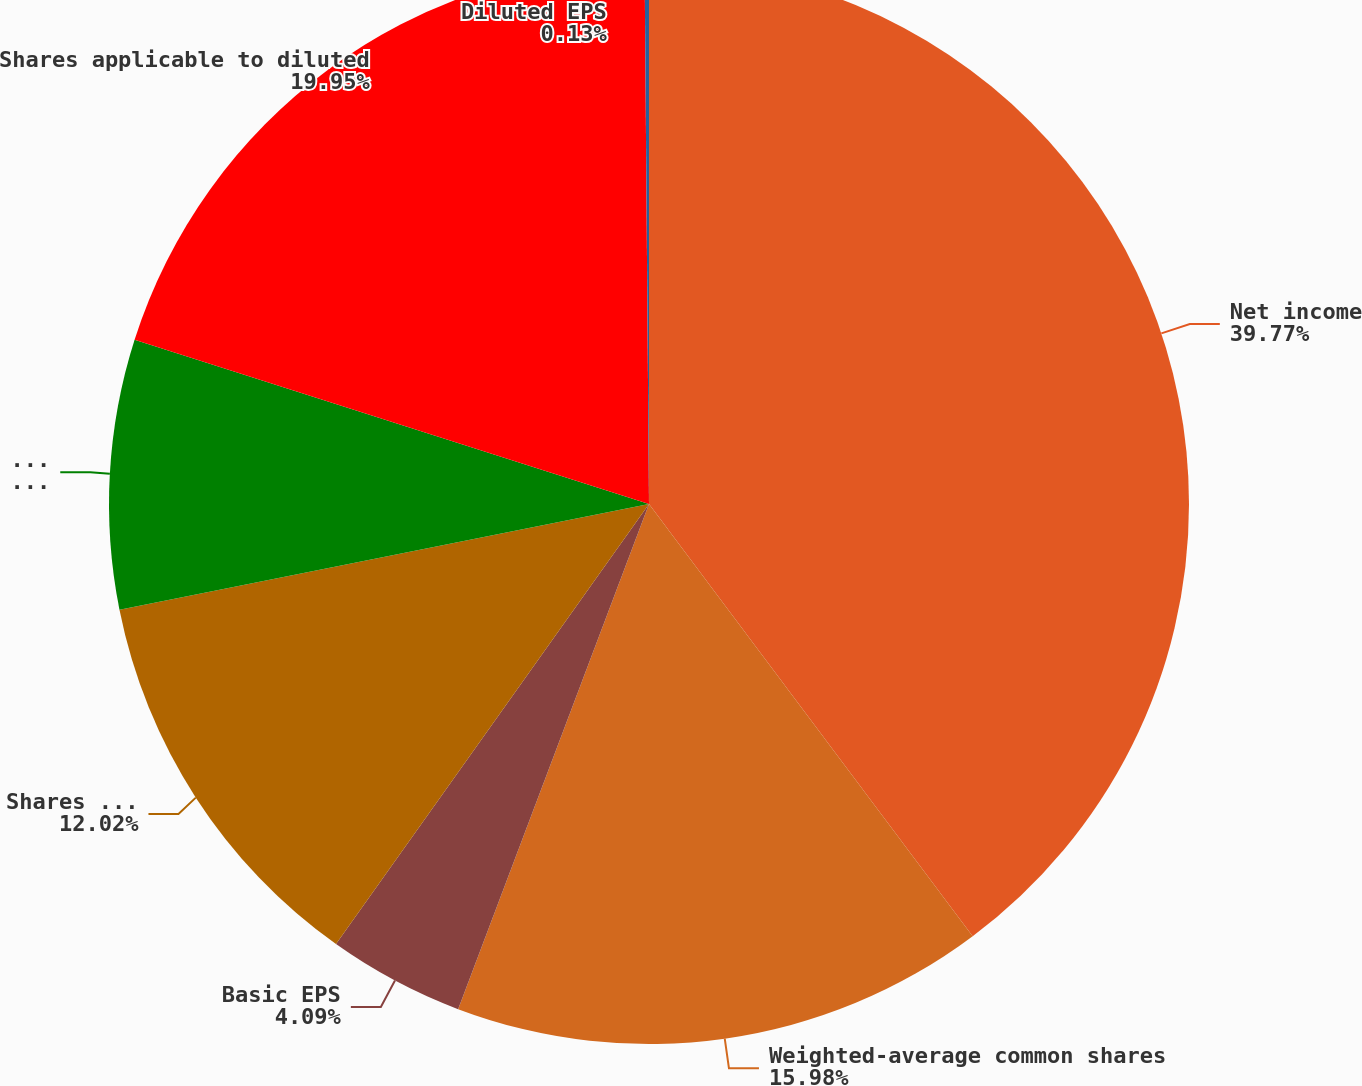Convert chart. <chart><loc_0><loc_0><loc_500><loc_500><pie_chart><fcel>Net income<fcel>Weighted-average common shares<fcel>Basic EPS<fcel>Shares assumed issued on<fcel>Shares assumed purchased with<fcel>Shares applicable to diluted<fcel>Diluted EPS<nl><fcel>39.77%<fcel>15.98%<fcel>4.09%<fcel>12.02%<fcel>8.06%<fcel>19.95%<fcel>0.13%<nl></chart> 